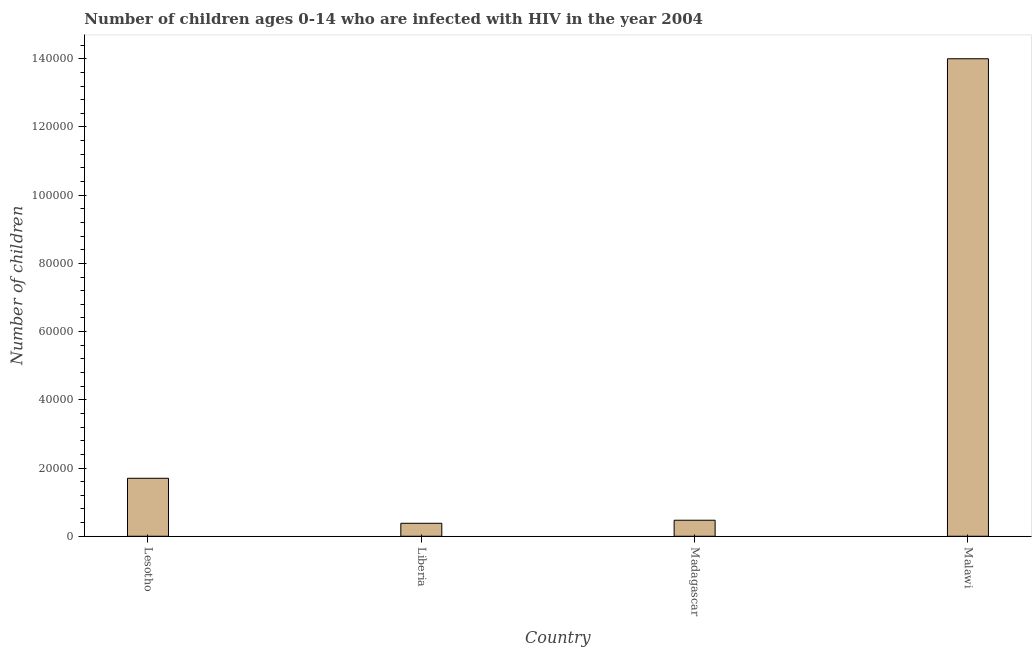What is the title of the graph?
Give a very brief answer. Number of children ages 0-14 who are infected with HIV in the year 2004. What is the label or title of the X-axis?
Provide a short and direct response. Country. What is the label or title of the Y-axis?
Make the answer very short. Number of children. What is the number of children living with hiv in Madagascar?
Provide a succinct answer. 4700. Across all countries, what is the maximum number of children living with hiv?
Provide a succinct answer. 1.40e+05. Across all countries, what is the minimum number of children living with hiv?
Keep it short and to the point. 3800. In which country was the number of children living with hiv maximum?
Ensure brevity in your answer.  Malawi. In which country was the number of children living with hiv minimum?
Offer a terse response. Liberia. What is the sum of the number of children living with hiv?
Your answer should be compact. 1.66e+05. What is the difference between the number of children living with hiv in Liberia and Malawi?
Ensure brevity in your answer.  -1.36e+05. What is the average number of children living with hiv per country?
Your answer should be compact. 4.14e+04. What is the median number of children living with hiv?
Provide a succinct answer. 1.08e+04. In how many countries, is the number of children living with hiv greater than 36000 ?
Keep it short and to the point. 1. What is the ratio of the number of children living with hiv in Lesotho to that in Madagascar?
Offer a very short reply. 3.62. What is the difference between the highest and the second highest number of children living with hiv?
Provide a short and direct response. 1.23e+05. Is the sum of the number of children living with hiv in Lesotho and Malawi greater than the maximum number of children living with hiv across all countries?
Your response must be concise. Yes. What is the difference between the highest and the lowest number of children living with hiv?
Give a very brief answer. 1.36e+05. In how many countries, is the number of children living with hiv greater than the average number of children living with hiv taken over all countries?
Make the answer very short. 1. Are all the bars in the graph horizontal?
Provide a succinct answer. No. What is the difference between two consecutive major ticks on the Y-axis?
Keep it short and to the point. 2.00e+04. Are the values on the major ticks of Y-axis written in scientific E-notation?
Your answer should be compact. No. What is the Number of children in Lesotho?
Keep it short and to the point. 1.70e+04. What is the Number of children in Liberia?
Provide a short and direct response. 3800. What is the Number of children in Madagascar?
Keep it short and to the point. 4700. What is the Number of children of Malawi?
Offer a terse response. 1.40e+05. What is the difference between the Number of children in Lesotho and Liberia?
Your answer should be compact. 1.32e+04. What is the difference between the Number of children in Lesotho and Madagascar?
Keep it short and to the point. 1.23e+04. What is the difference between the Number of children in Lesotho and Malawi?
Ensure brevity in your answer.  -1.23e+05. What is the difference between the Number of children in Liberia and Madagascar?
Your answer should be compact. -900. What is the difference between the Number of children in Liberia and Malawi?
Keep it short and to the point. -1.36e+05. What is the difference between the Number of children in Madagascar and Malawi?
Your answer should be very brief. -1.35e+05. What is the ratio of the Number of children in Lesotho to that in Liberia?
Offer a very short reply. 4.47. What is the ratio of the Number of children in Lesotho to that in Madagascar?
Your answer should be very brief. 3.62. What is the ratio of the Number of children in Lesotho to that in Malawi?
Your response must be concise. 0.12. What is the ratio of the Number of children in Liberia to that in Madagascar?
Your answer should be very brief. 0.81. What is the ratio of the Number of children in Liberia to that in Malawi?
Provide a short and direct response. 0.03. What is the ratio of the Number of children in Madagascar to that in Malawi?
Offer a very short reply. 0.03. 